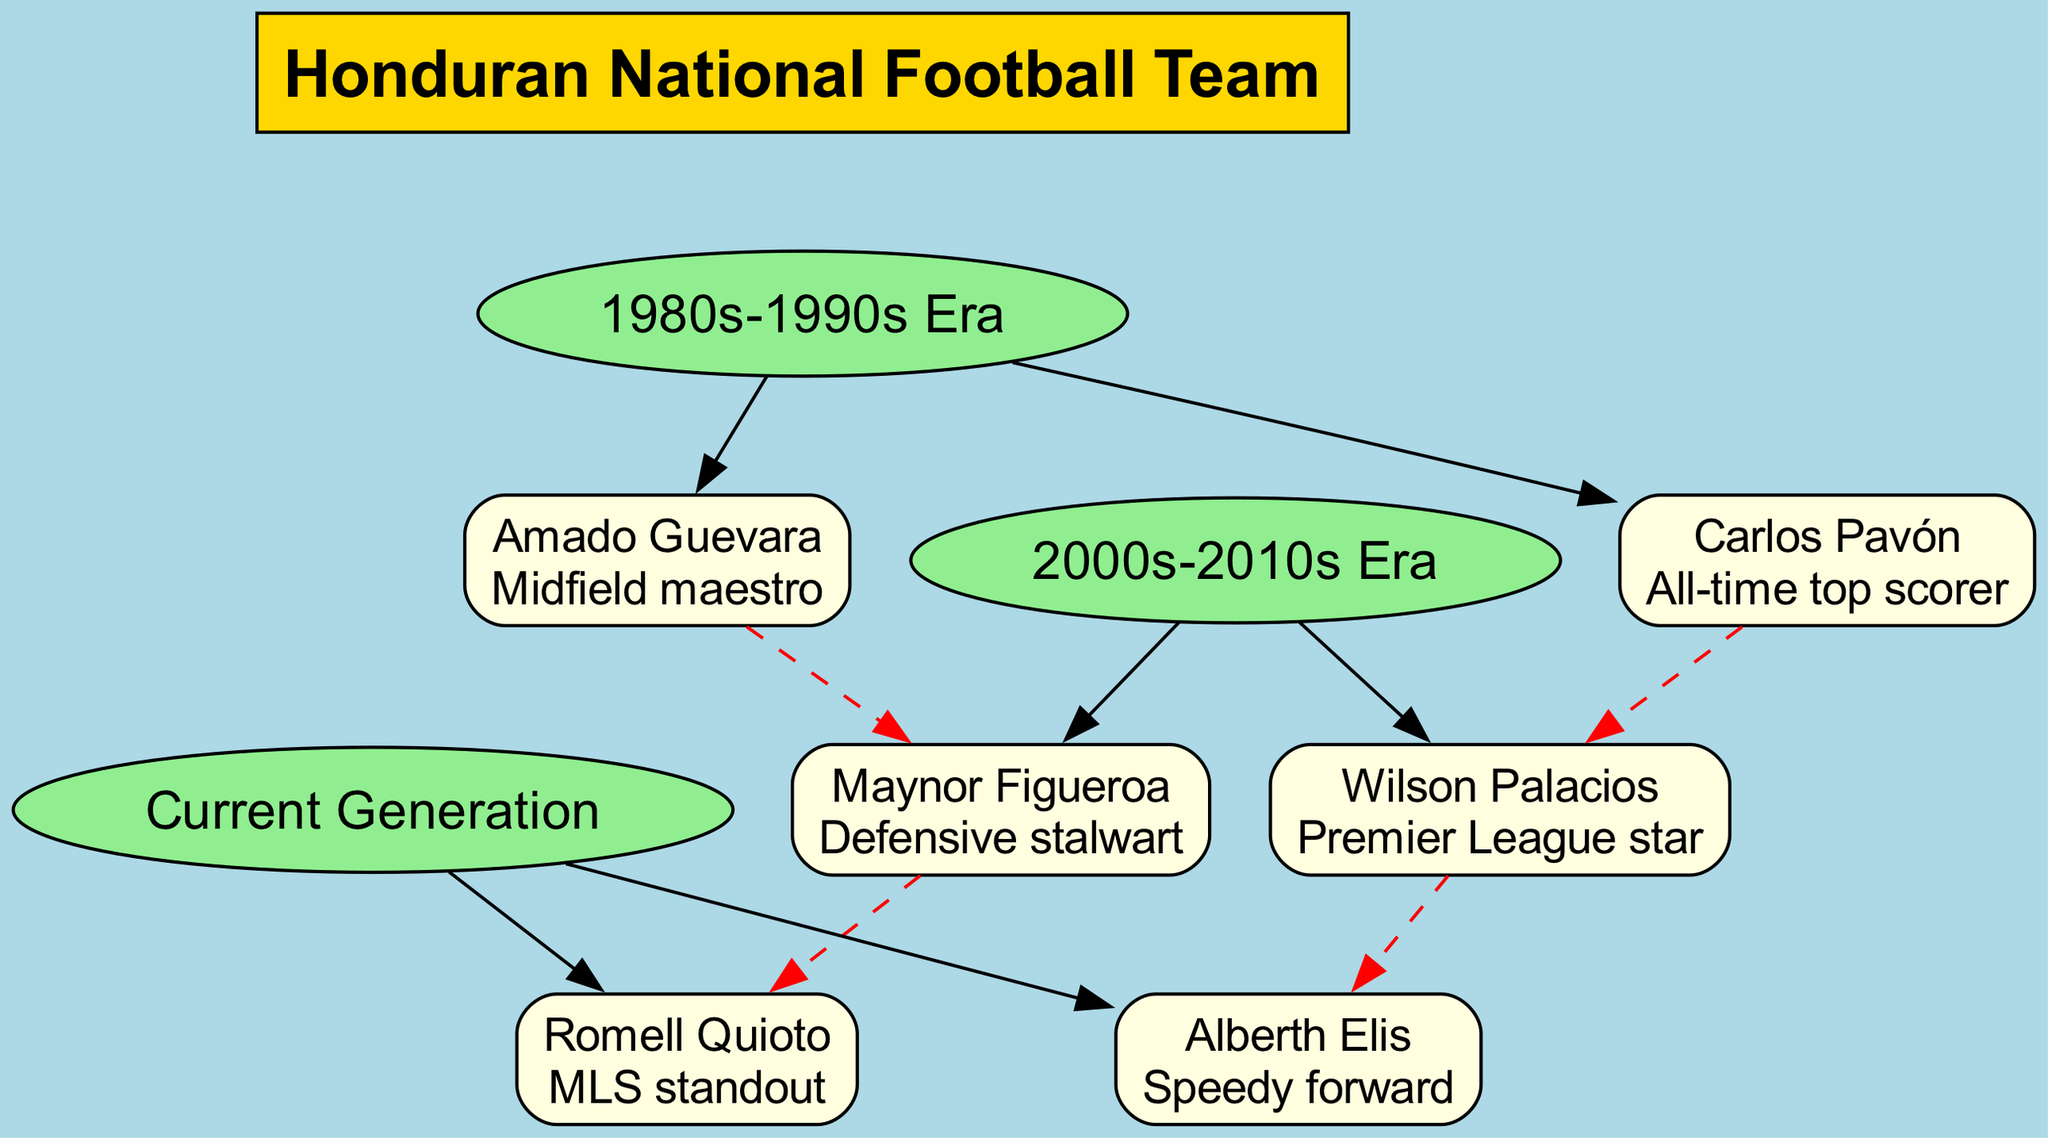What is the root of the family tree? The root of the family tree is defined as the main node from which all other nodes branch out. In this case, it represents the overall entity of the diagram, which is the "Honduran National Football Team."
Answer: Honduran National Football Team Who is the all-time top scorer? By looking at the first generation represented under the "1980s-1990s Era," the member listed as "Carlos Pavón" is explicitly described as the "All-time top scorer," making him the answer.
Answer: Carlos Pavón How many players are in the 2000s-2010s Era? This involves counting the number of members under the "2000s-2010s Era." There are two members, Wilson Palacios and Maynor Figueroa.
Answer: 2 What is the connection between Wilson Palacios and Carlos Pavón? The diagram shows that Wilson Palacios has a connection to Carlos Pavón indicated by a dashed red line, which signifies a relationship from the 1980s-1990s Era to the 2000s-2010s Era.
Answer: Carlos Pavón Which player in the Current Generation is connected to Maynor Figueroa? The Current Generation lists Romell Quioto, who is specifically mentioned to have a connection to Maynor Figueroa. This connection can be traced through the dashed line in the diagram.
Answer: Romell Quioto Who is the defensive stalwart in the 2000s-2010s Era? Looking at the details provided in the "2000s-2010s Era," Maynor Figueroa is clearly labeled as the "Defensive stalwart," making this the direct answer.
Answer: Maynor Figueroa What role did Amado Guevara play? The diagram categorizes Amado Guevara's role in the team as the "Midfield maestro" under the members of the first generation, which indicates his influence on the field.
Answer: Midfield maestro How many generations are represented in the diagram? By analyzing the groups listed under "generations," there are three distinct eras: 1980s-1990s Era, 2000s-2010s Era, and Current Generation. Counting these gives the number of generations represented.
Answer: 3 Who is the speedy forward in the Current Generation? In the section labeled "Current Generation," the player identified as the "Speedy forward" is Alberth Elis, making him the answer.
Answer: Alberth Elis 